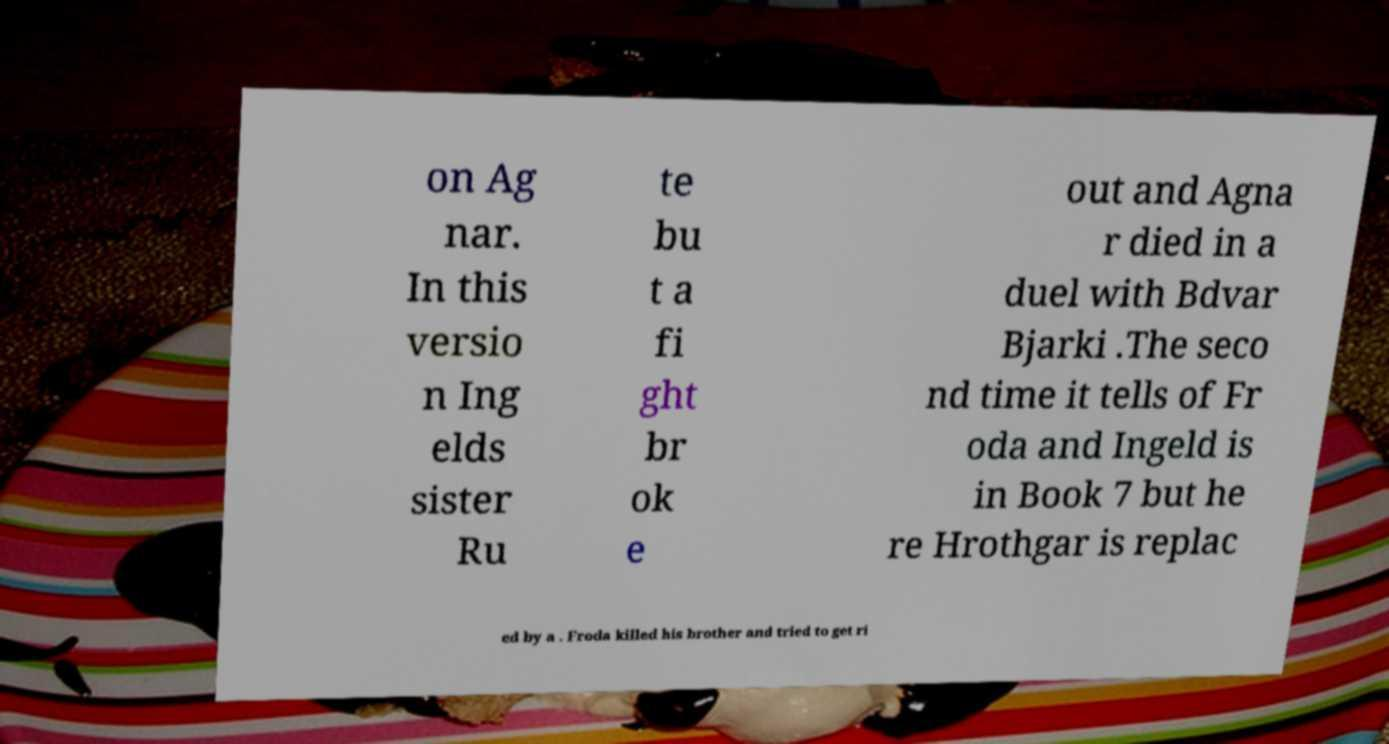Can you accurately transcribe the text from the provided image for me? on Ag nar. In this versio n Ing elds sister Ru te bu t a fi ght br ok e out and Agna r died in a duel with Bdvar Bjarki .The seco nd time it tells of Fr oda and Ingeld is in Book 7 but he re Hrothgar is replac ed by a . Froda killed his brother and tried to get ri 